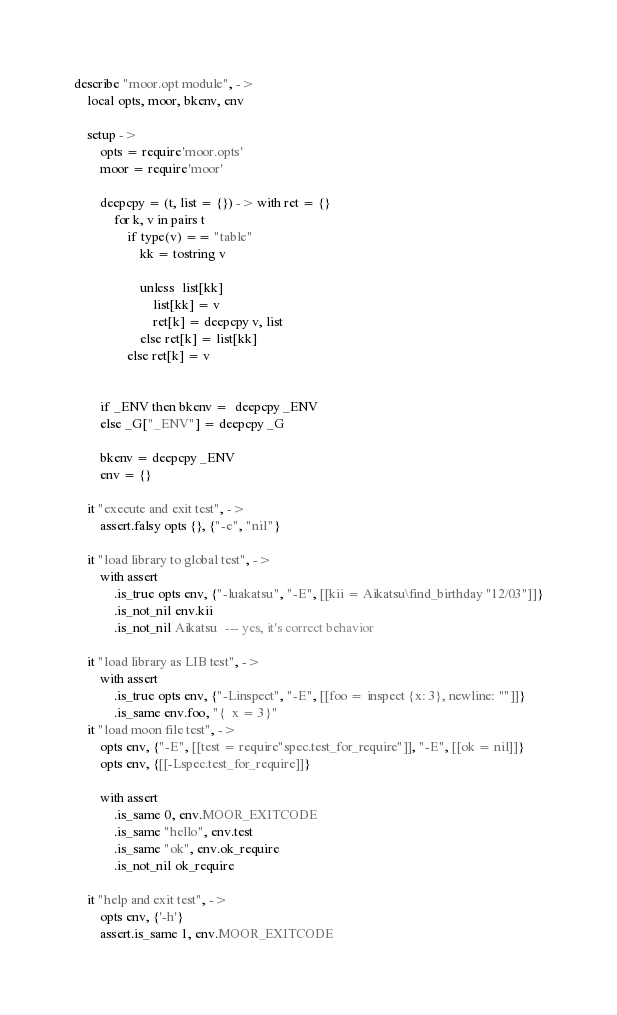<code> <loc_0><loc_0><loc_500><loc_500><_MoonScript_>describe "moor.opt module", ->
	local opts, moor, bkenv, env

	setup ->
		opts = require'moor.opts'
		moor = require'moor'

		deepcpy = (t, list = {}) -> with ret = {}
			for k, v in pairs t
				if type(v) == "table"
					kk = tostring v
					
					unless  list[kk]
						list[kk] = v
						ret[k] = deepcpy v, list
					else ret[k] = list[kk]
				else ret[k] = v


		if _ENV then bkenv =  deepcpy _ENV
		else _G["_ENV"] = deepcpy _G

		bkenv = deepcpy _ENV
		env = {}

	it "execute and exit test", ->
		assert.falsy opts {}, {"-e", "nil"}

	it "load library to global test", ->
		with assert
			.is_true opts env, {"-luakatsu", "-E", [[kii = Aikatsu\find_birthday "12/03"]]}
			.is_not_nil env.kii
			.is_not_nil Aikatsu  --- yes, it's correct behavior

	it "load library as LIB test", ->
		with assert
			.is_true opts env, {"-Linspect", "-E", [[foo = inspect {x: 3}, newline: ""]]}
			.is_same env.foo, "{  x = 3}"
	it "load moon file test", ->
		opts env, {"-E", [[test = require"spec.test_for_require"]], "-E", [[ok = nil]]}
		opts env, {[[-Lspec.test_for_require]]}

		with assert
			.is_same 0, env.MOOR_EXITCODE
			.is_same "hello", env.test
			.is_same "ok", env.ok_require
			.is_not_nil ok_require

	it "help and exit test", ->
		opts env, {'-h'}
		assert.is_same 1, env.MOOR_EXITCODE

</code> 